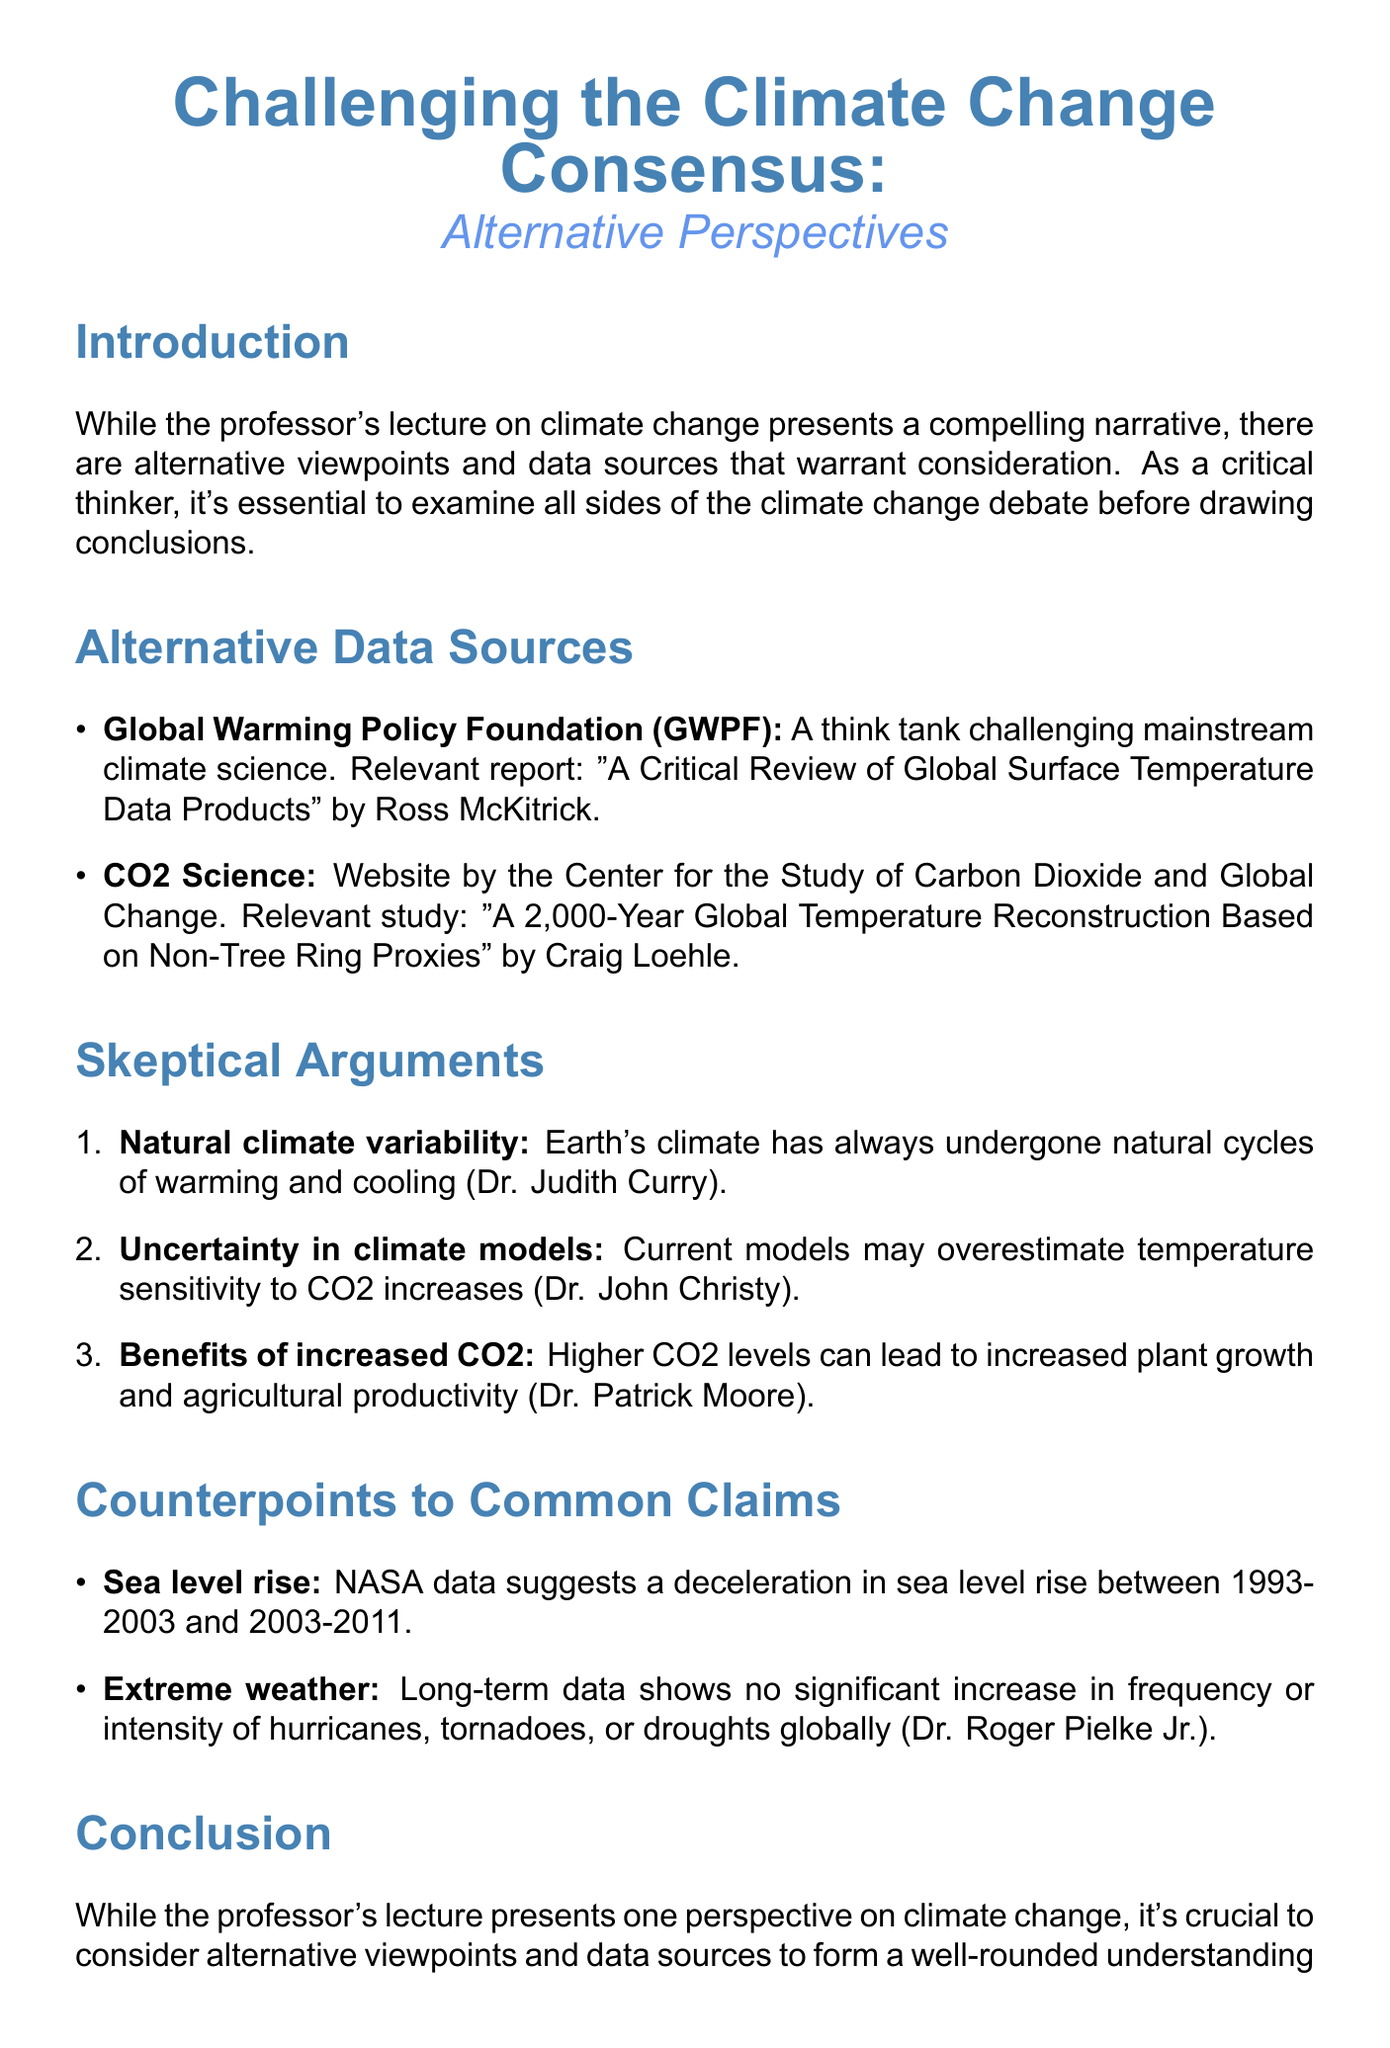What is the title of the memo? The title of the memo is an important piece of information that provides insight into its subject matter and main argument.
Answer: Challenging the Climate Change Consensus: Alternative Perspectives Who authored the relevant report from GWPF? The author of the relevant report is mentioned in the section about alternative data sources, which provides details for readers to explore further.
Answer: Ross McKitrick What does Dr. Judith Curry argue? This question asks for the argument made by a specific expert referenced in the document, highlighting the perspectives taken by those skeptical of mainstream climate science.
Answer: Natural climate variability What time period does the NASA data address regarding sea level rise? Understanding the time frames referred to in the counterpoints helps in evaluating claims and counterclaims about climate data.
Answer: 1993-2003 and 2003-2011 Which organization maintains the CO2 Science website? The name of the organization provides context to the data presented and may determine its credibility based on the audience’s perspective.
Answer: Center for the Study of Carbon Dioxide and Global Change What does the conclusion of the memo summarize? The conclusion encapsulates the premises of the memo, emphasizing the importance of the alternative viewpoints discussed throughout the document.
Answer: Importance of alternative viewpoints and data sources What is the call to action for students? The call to action offers a directive for readers, suggesting a course of engagement in the climate change debate.
Answer: Question assumptions, seek diverse sources of information 